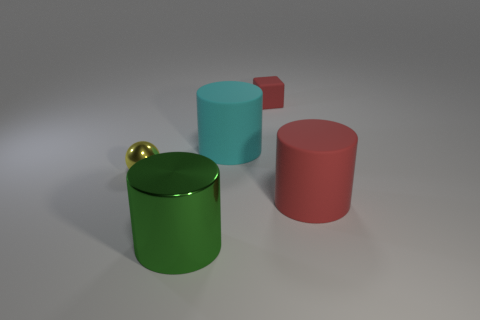How does the lighting in this scene affect the appearance of the objects? The lighting creates soft shadows and subtle reflections, enhancing the objects' three-dimensional forms. The gentle illumination on the tops suggests a diffuse light source, giving the scene a calm ambiance. 